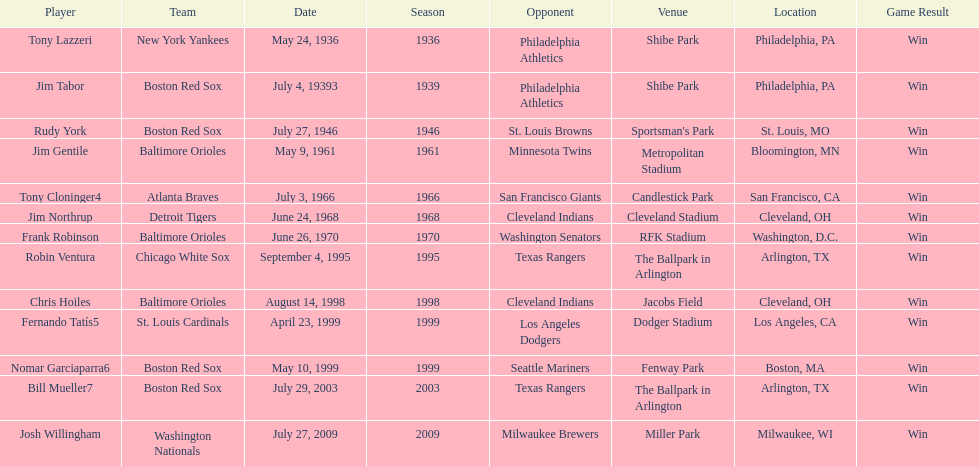On what date did the detroit tigers play the cleveland indians? June 24, 1968. 